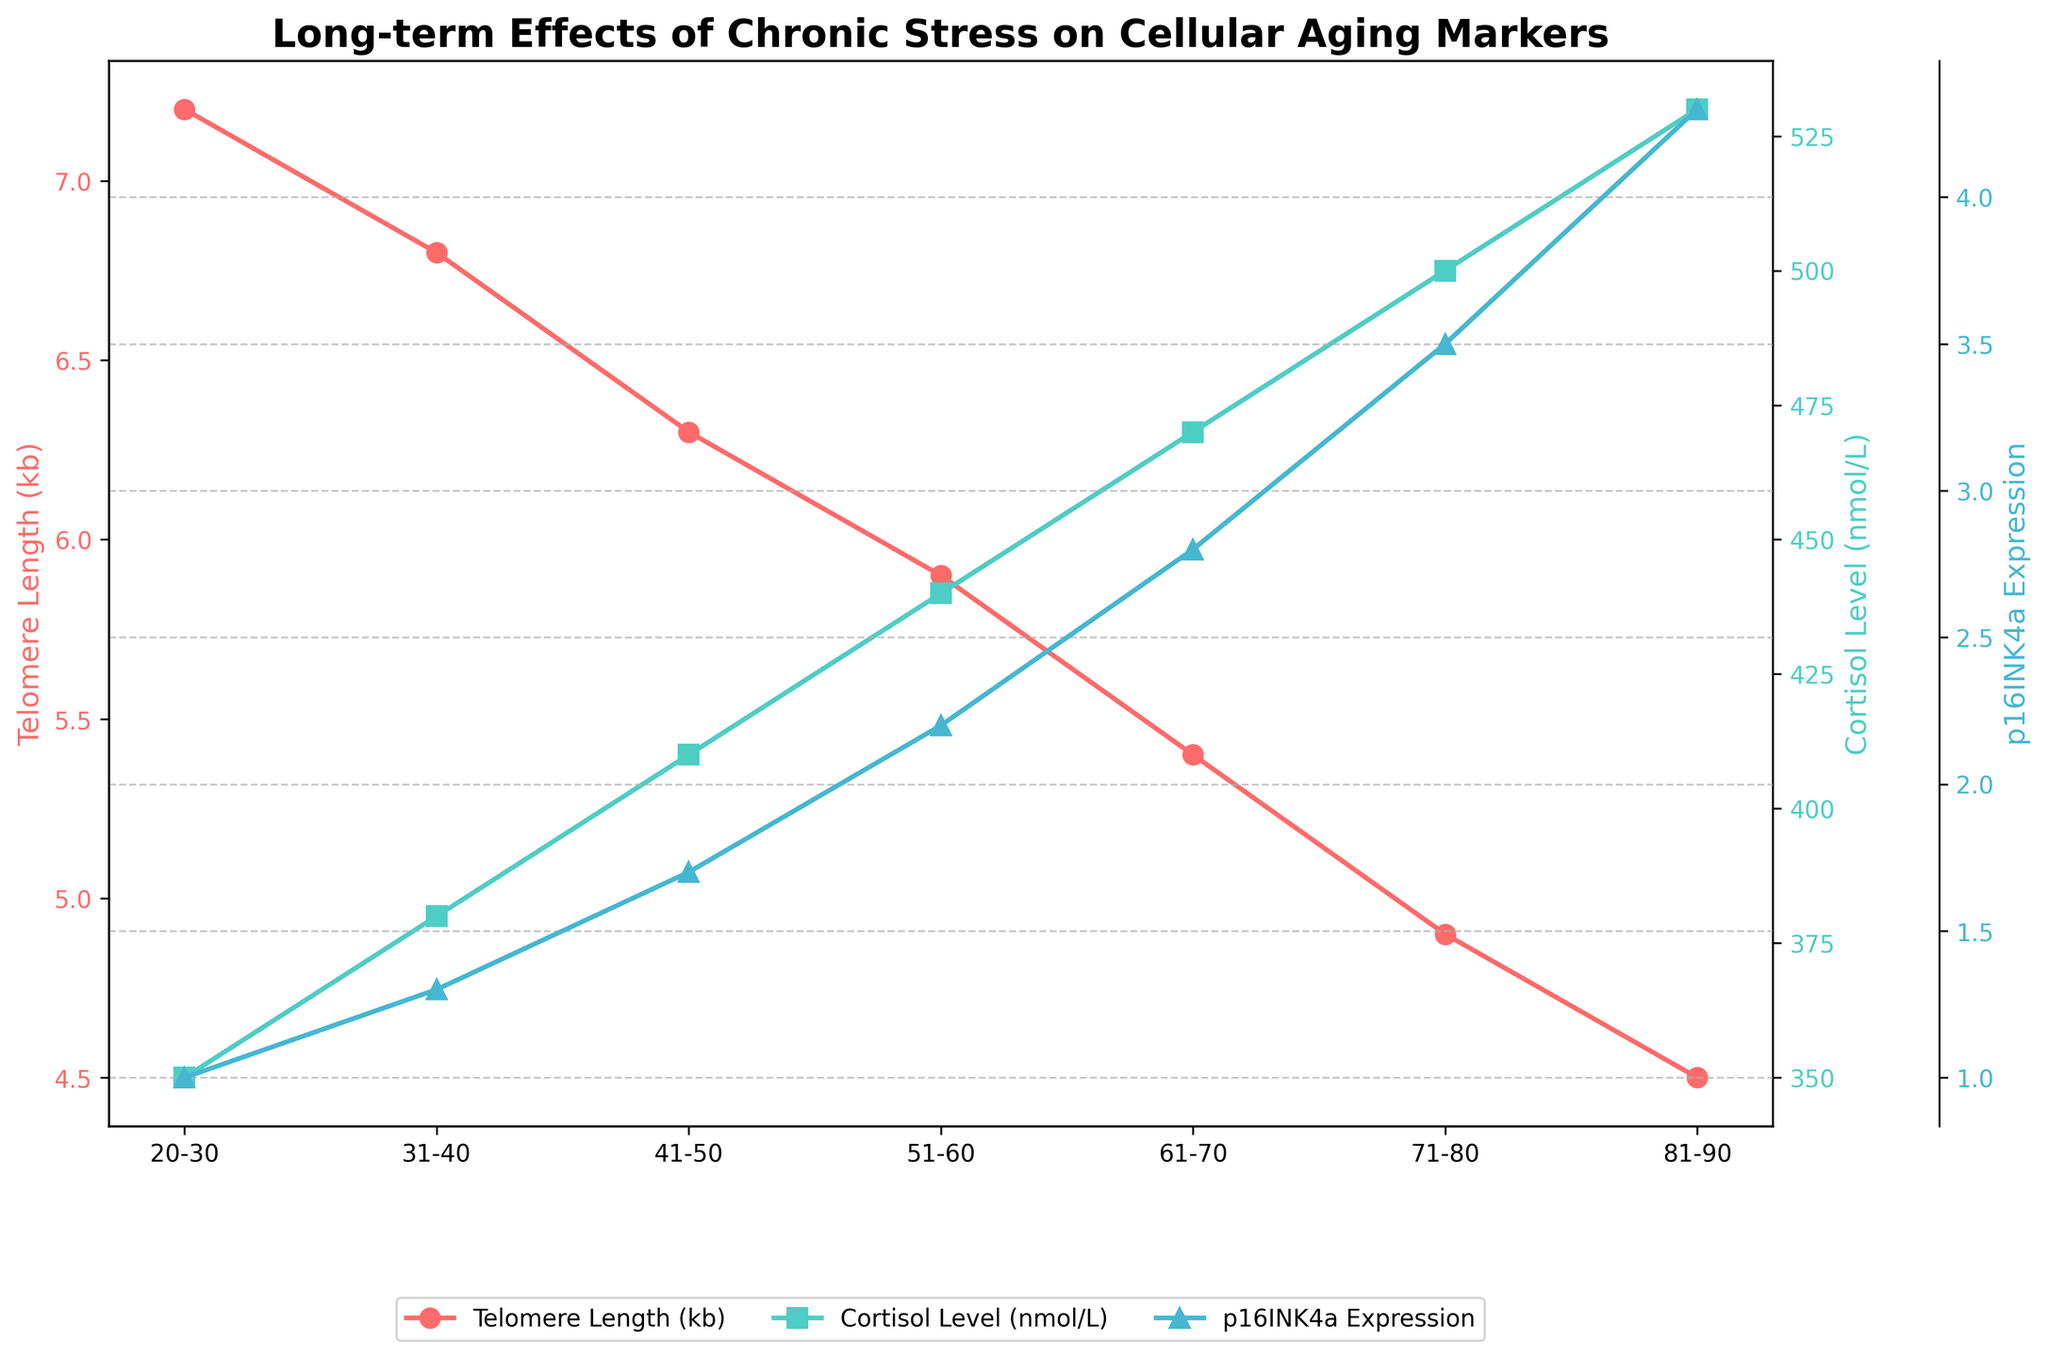What happens to telomere length as age increases? By observing the red line representing telomere length, it shows a decreasing trend with age. Starting from a length of 7.2 kb in the 20-30 age group, it decreases progressively to 4.5 kb in the 81-90 age group.
Answer: Decreases Which age group has the highest cortisol level? The green line for cortisol level shows that the 81-90 age group has the highest cortisol level, reaching 530 nmol/L.
Answer: 81-90 How does p16INK4a expression change relative to cortisol levels as age progresses? Both the blue line for p16INK4a expression and the green line for cortisol levels increase with age. p16INK4a expression follows a similar upward trend from 1.0 to 4.3, correlating with the increase in cortisol levels from 350 to 530 nmol/L.
Answer: Both increase What is the difference in telomere length between the 20-30 age group and the 71-80 age group? The telomere length for ages 20-30 is 7.2 kb and for ages 71-80 is 4.9 kb. Subtracting these values gives a difference of 2.3 kb.
Answer: 2.3 kb Which marker shows the steepest increase as age progresses? By comparing the slopes of the lines, the blue line for p16INK4a expression shows the steepest increase, rising from 1.0 at age 20-30 to 4.3 at age 81-90.
Answer: p16INK4a expression Is there a relationship between oxidative stress markers and mitochondrial DNA copy number? The oxidative stress marker (grey line) increases with age, from 2.1 to 4.8 ng/mL, while the mitochondrial DNA copy number (black line) decreases with age, from 850 to 670. This shows an inverse relationship.
Answer: Inverse relationship What trend do the markers show in the 61-70 age group compared to the 41-50 age group? For the 61-70 age group compared to the 41-50 age group, telomere length decreases from 6.3 to 5.4 kb, cortisol level increases from 410 to 470 nmol/L, p16INK4a expression goes up from 1.7 to 2.8, oxidative stress marker increases from 2.8 to 3.7, and mitochondrial DNA copy number decreases from 790 to 730.
Answer: Telomere length decreases, cortisol level increases, p16INK4a expression increases, oxidative stress increases, mitochondrial DNA decreases How does the telomere length change per decade? By calculating the difference in telomere length per decade; 20-30 to 31-40: 7.2 to 6.8 (-0.4 kb), 31-40 to 41-50: 6.8 to 6.3 (-0.5 kb), 41-50 to 51-60: 6.3 to 5.9 (-0.4 kb), 51-60 to 61-70: 5.9 to 5.4 (-0.5 kb), 61-70 to 71-80: 5.4 to 4.9 (-0.5 kb), 71-80 to 81-90: 4.9 to 4.5 (-0.4 kb). On average, telomere length decreases by approximately 0.47 kb per decade.
Answer: -0.47 kb per decade 